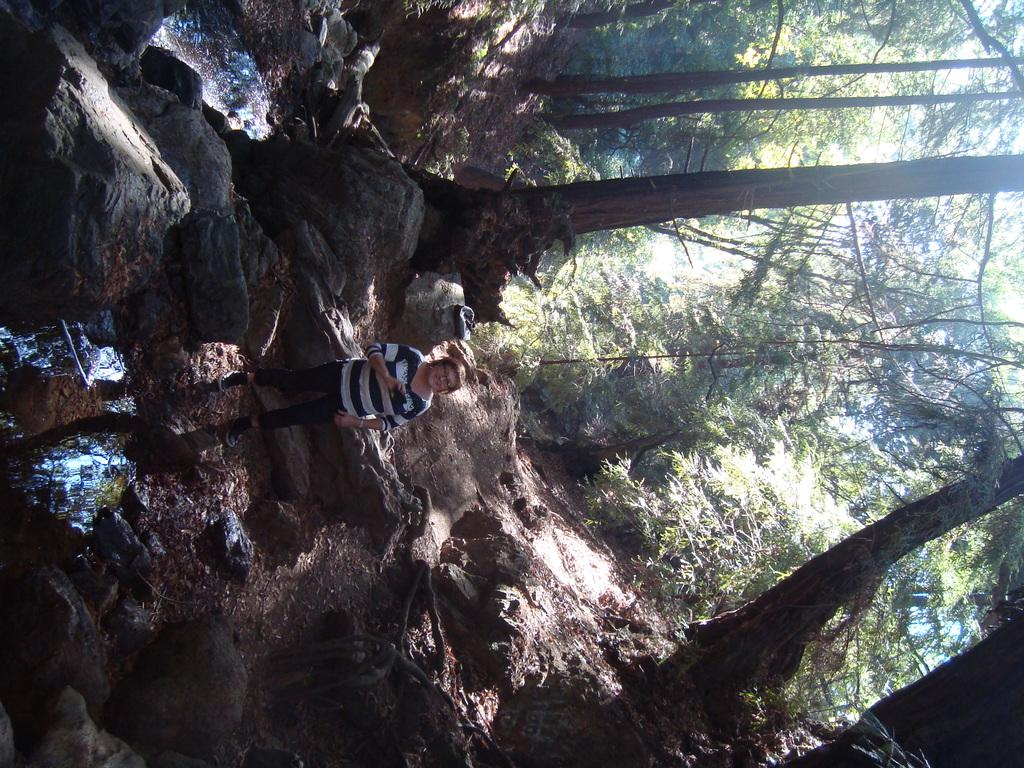Who is the main subject in the image? There is a lady standing in the image. What is the lady standing on or near? The lady is standing between rocks. What is visible in front of the lady? There is water in front of the lady. What can be seen in the background of the image? There are trees in the background of the image. What type of grass is growing on the lady's head in the image? There is no grass growing on the lady's head in the image. 